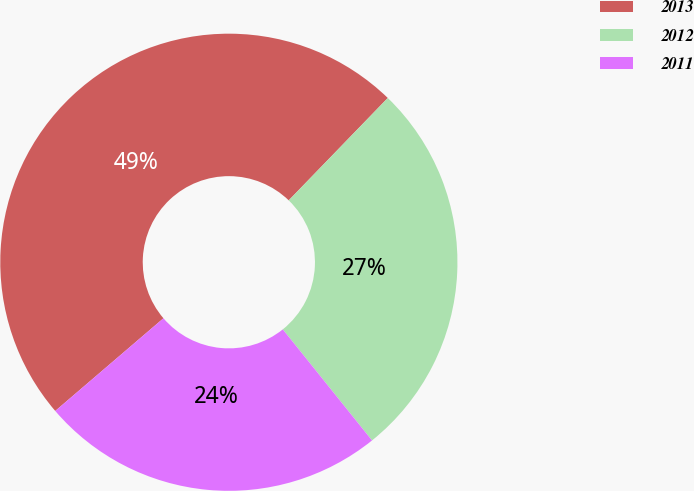Convert chart. <chart><loc_0><loc_0><loc_500><loc_500><pie_chart><fcel>2013<fcel>2012<fcel>2011<nl><fcel>48.51%<fcel>26.99%<fcel>24.5%<nl></chart> 